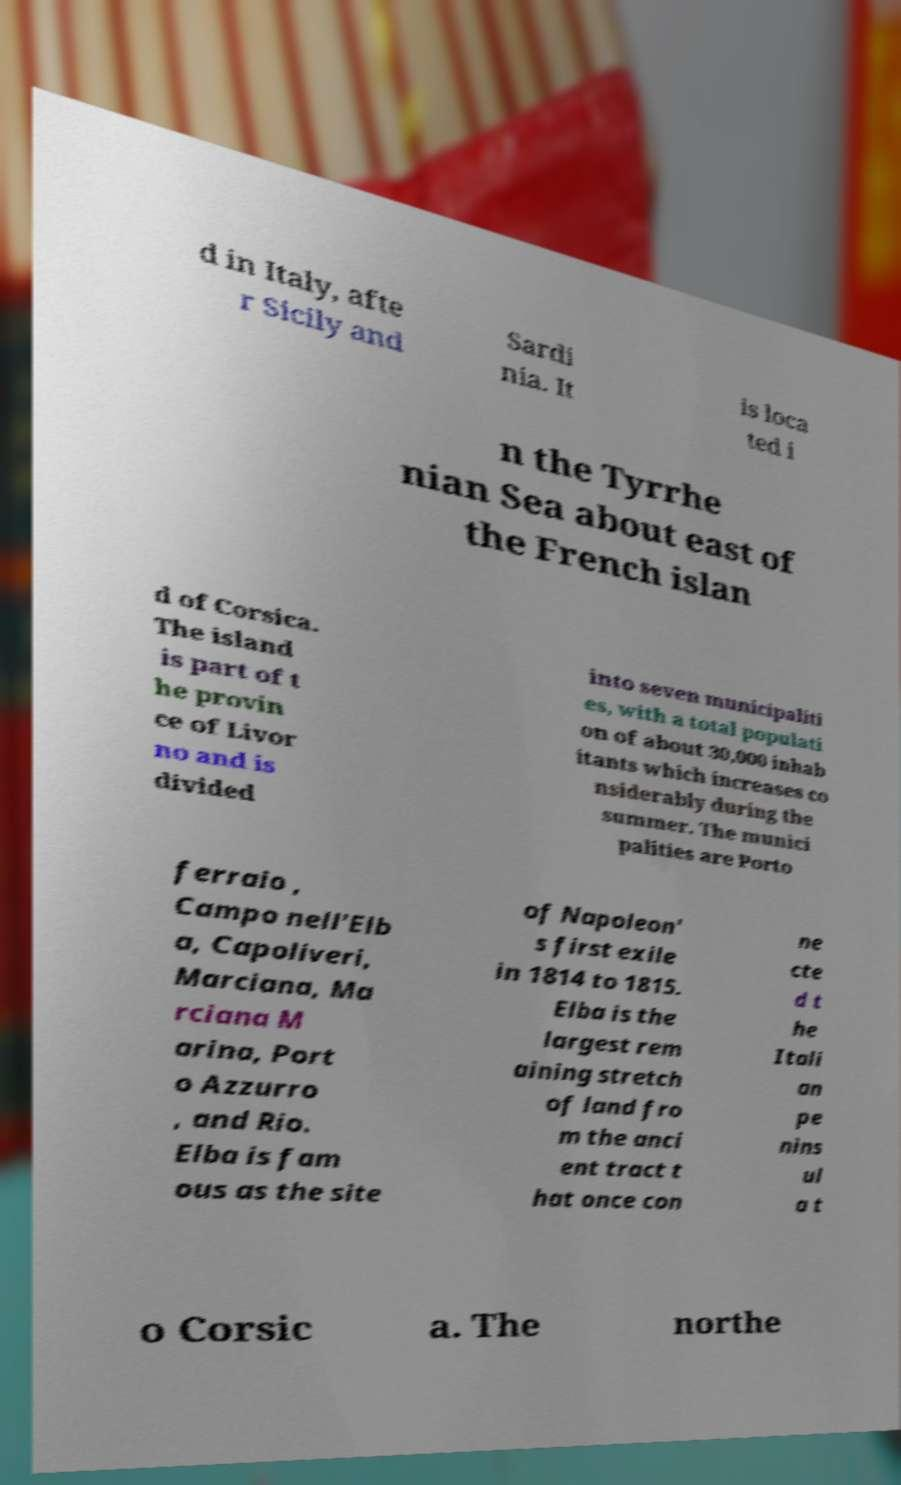Could you extract and type out the text from this image? d in Italy, afte r Sicily and Sardi nia. It is loca ted i n the Tyrrhe nian Sea about east of the French islan d of Corsica. The island is part of t he provin ce of Livor no and is divided into seven municipaliti es, with a total populati on of about 30,000 inhab itants which increases co nsiderably during the summer. The munici palities are Porto ferraio , Campo nell'Elb a, Capoliveri, Marciana, Ma rciana M arina, Port o Azzurro , and Rio. Elba is fam ous as the site of Napoleon' s first exile in 1814 to 1815. Elba is the largest rem aining stretch of land fro m the anci ent tract t hat once con ne cte d t he Itali an pe nins ul a t o Corsic a. The northe 